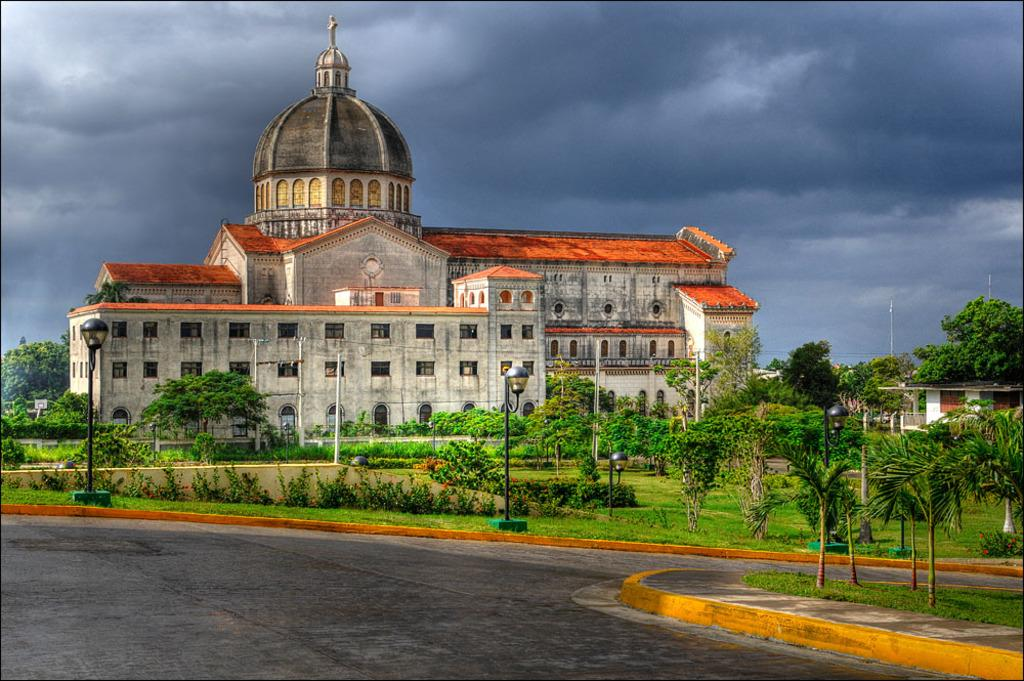What type of structure is present in the image? There is a building in the image. What natural elements can be seen in the image? There are many trees and plants in the image. What part of the sky is visible in the image? The sky is visible in the image, and there are clouds present. What man-made feature can be seen in the image? There is a road in the image. How does the feeling of happiness manifest itself in the image? There is no mention of any emotions or feelings in the image, so it is not possible to determine how happiness might be represented. 